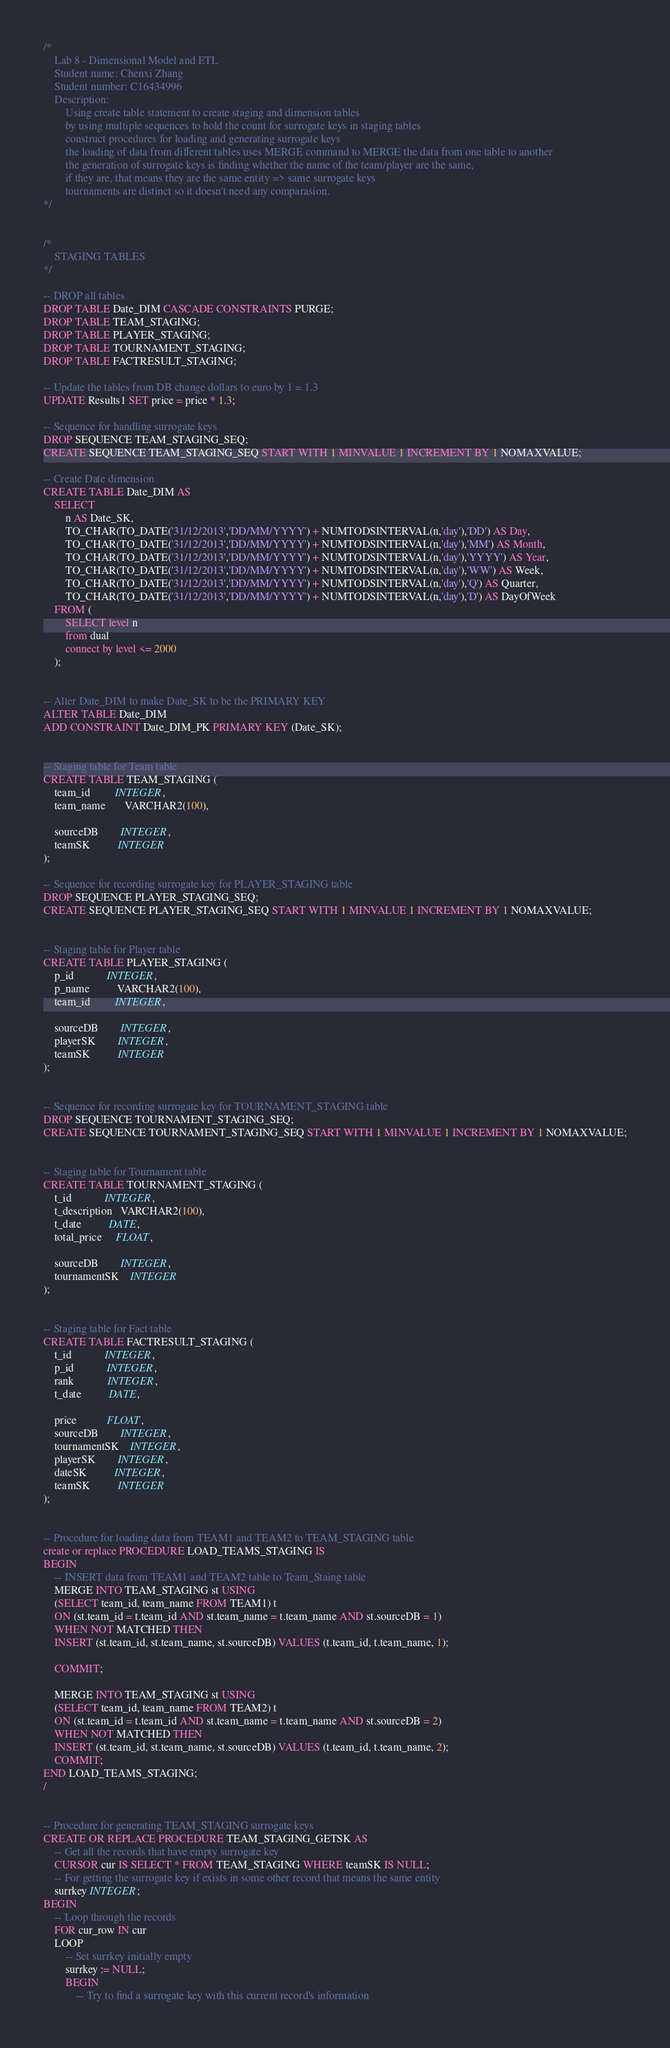<code> <loc_0><loc_0><loc_500><loc_500><_SQL_>/* 
    Lab 8 - Dimensional Model and ETL
    Student name: Chenxi Zhang
    Student number: C16434996
    Description: 
        Using create table statement to create staging and dimension tables
        by using multiple sequences to hold the count for surrogate keys in staging tables
        construct procedures for loading and generating surrogate keys
        the loading of data from different tables uses MERGE command to MERGE the data from one table to another
        the generation of surrogate keys is finding whether the name of the team/player are the same,
        if they are, that means they are the same entity => same surrogate keys
        tournaments are distinct so it doesn't need any comparasion.
*/


/*
    STAGING TABLES
*/

-- DROP all tables
DROP TABLE Date_DIM CASCADE CONSTRAINTS PURGE;
DROP TABLE TEAM_STAGING;
DROP TABLE PLAYER_STAGING;
DROP TABLE TOURNAMENT_STAGING;
DROP TABLE FACTRESULT_STAGING;

-- Update the tables from DB change dollars to euro by 1 = 1.3
UPDATE Results1 SET price = price * 1.3;

-- Sequence for handling surrogate keys
DROP SEQUENCE TEAM_STAGING_SEQ;
CREATE SEQUENCE TEAM_STAGING_SEQ START WITH 1 MINVALUE 1 INCREMENT BY 1 NOMAXVALUE;

-- Create Date dimension
CREATE TABLE Date_DIM AS
    SELECT
        n AS Date_SK,
        TO_CHAR(TO_DATE('31/12/2013','DD/MM/YYYY') + NUMTODSINTERVAL(n,'day'),'DD') AS Day,
        TO_CHAR(TO_DATE('31/12/2013','DD/MM/YYYY') + NUMTODSINTERVAL(n,'day'),'MM') AS Month,
        TO_CHAR(TO_DATE('31/12/2013','DD/MM/YYYY') + NUMTODSINTERVAL(n,'day'),'YYYY') AS Year,
        TO_CHAR(TO_DATE('31/12/2013','DD/MM/YYYY') + NUMTODSINTERVAL(n,'day'),'WW') AS Week,
        TO_CHAR(TO_DATE('31/12/2013','DD/MM/YYYY') + NUMTODSINTERVAL(n,'day'),'Q') AS Quarter,
        TO_CHAR(TO_DATE('31/12/2013','DD/MM/YYYY') + NUMTODSINTERVAL(n,'day'),'D') AS DayOfWeek
    FROM (
        SELECT level n
        from dual
        connect by level <= 2000
    );


-- Alter Date_DIM to make Date_SK to be the PRIMARY KEY
ALTER TABLE Date_DIM
ADD CONSTRAINT Date_DIM_PK PRIMARY KEY (Date_SK);


-- Staging table for Team table
CREATE TABLE TEAM_STAGING (
    team_id         INTEGER,
    team_name       VARCHAR2(100),
    
    sourceDB        INTEGER,
    teamSK          INTEGER
);

-- Sequence for recording surrogate key for PLAYER_STAGING table
DROP SEQUENCE PLAYER_STAGING_SEQ;
CREATE SEQUENCE PLAYER_STAGING_SEQ START WITH 1 MINVALUE 1 INCREMENT BY 1 NOMAXVALUE;


-- Staging table for Player table
CREATE TABLE PLAYER_STAGING (
    p_id            INTEGER,
    p_name          VARCHAR2(100),
    team_id         INTEGER,
    
    sourceDB        INTEGER,
    playerSK        INTEGER,
    teamSK          INTEGER
);


-- Sequence for recording surrogate key for TOURNAMENT_STAGING table
DROP SEQUENCE TOURNAMENT_STAGING_SEQ;
CREATE SEQUENCE TOURNAMENT_STAGING_SEQ START WITH 1 MINVALUE 1 INCREMENT BY 1 NOMAXVALUE;


-- Staging table for Tournament table
CREATE TABLE TOURNAMENT_STAGING (
    t_id            INTEGER,
    t_description   VARCHAR2(100),
    t_date          DATE,
    total_price     FLOAT,

    sourceDB        INTEGER,
    tournamentSK    INTEGER
);


-- Staging table for Fact table
CREATE TABLE FACTRESULT_STAGING (
    t_id            INTEGER,
    p_id            INTEGER,
    rank            INTEGER,
    t_date          DATE,

    price           FLOAT,
    sourceDB        INTEGER,
    tournamentSK    INTEGER,
    playerSK        INTEGER,
    dateSK          INTEGER,
    teamSK          INTEGER
);


-- Procedure for loading data from TEAM1 and TEAM2 to TEAM_STAGING table
create or replace PROCEDURE LOAD_TEAMS_STAGING IS
BEGIN
    -- INSERT data from TEAM1 and TEAM2 table to Team_Staing table
    MERGE INTO TEAM_STAGING st USING
    (SELECT team_id, team_name FROM TEAM1) t
    ON (st.team_id = t.team_id AND st.team_name = t.team_name AND st.sourceDB = 1)
    WHEN NOT MATCHED THEN
    INSERT (st.team_id, st.team_name, st.sourceDB) VALUES (t.team_id, t.team_name, 1);

    COMMIT;

    MERGE INTO TEAM_STAGING st USING
    (SELECT team_id, team_name FROM TEAM2) t
    ON (st.team_id = t.team_id AND st.team_name = t.team_name AND st.sourceDB = 2)
    WHEN NOT MATCHED THEN
    INSERT (st.team_id, st.team_name, st.sourceDB) VALUES (t.team_id, t.team_name, 2);
    COMMIT;
END LOAD_TEAMS_STAGING;
/


-- Procedure for generating TEAM_STAGING surrogate keys
CREATE OR REPLACE PROCEDURE TEAM_STAGING_GETSK AS
    -- Get all the records that have empty surrogate key
    CURSOR cur IS SELECT * FROM TEAM_STAGING WHERE teamSK IS NULL;
    -- For getting the surrogate key if exists in some other record that means the same entity
    surrkey INTEGER;
BEGIN
    -- Loop through the records
    FOR cur_row IN cur
    LOOP
        -- Set surrkey initially empty
        surrkey := NULL;
        BEGIN
            -- Try to find a surrogate key with this current record's information</code> 